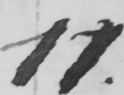Transcribe the text shown in this historical manuscript line. 11 . 